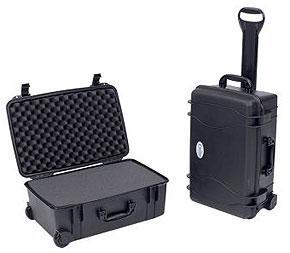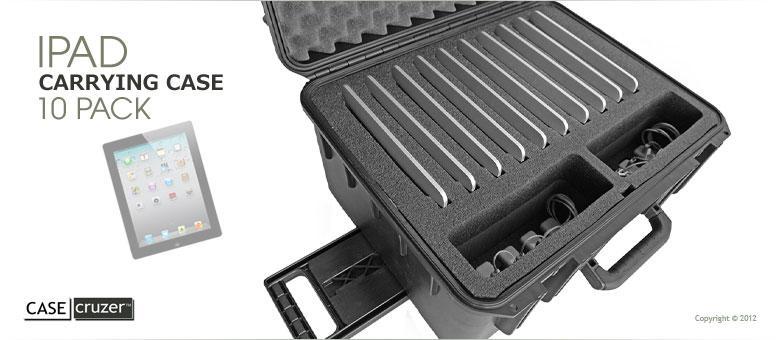The first image is the image on the left, the second image is the image on the right. Given the left and right images, does the statement "One of the cases shown is closed, standing upright, and has a handle sticking out of the top for pushing or pulling the case." hold true? Answer yes or no. Yes. The first image is the image on the left, the second image is the image on the right. Considering the images on both sides, is "A carrying case stands upright and closed with another case in one of the images." valid? Answer yes or no. Yes. 